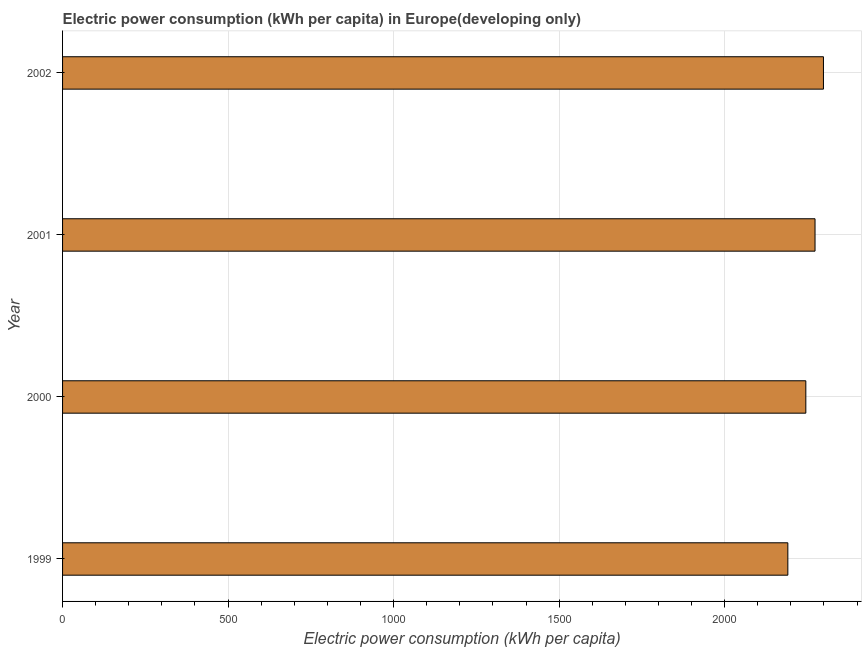Does the graph contain grids?
Make the answer very short. Yes. What is the title of the graph?
Offer a terse response. Electric power consumption (kWh per capita) in Europe(developing only). What is the label or title of the X-axis?
Offer a terse response. Electric power consumption (kWh per capita). What is the electric power consumption in 2000?
Give a very brief answer. 2245.15. Across all years, what is the maximum electric power consumption?
Your answer should be very brief. 2298.36. Across all years, what is the minimum electric power consumption?
Your response must be concise. 2190.83. In which year was the electric power consumption minimum?
Make the answer very short. 1999. What is the sum of the electric power consumption?
Offer a terse response. 9007.29. What is the difference between the electric power consumption in 1999 and 2000?
Give a very brief answer. -54.33. What is the average electric power consumption per year?
Make the answer very short. 2251.82. What is the median electric power consumption?
Keep it short and to the point. 2259.05. In how many years, is the electric power consumption greater than 200 kWh per capita?
Provide a short and direct response. 4. Is the difference between the electric power consumption in 1999 and 2001 greater than the difference between any two years?
Offer a terse response. No. What is the difference between the highest and the second highest electric power consumption?
Offer a very short reply. 25.41. What is the difference between the highest and the lowest electric power consumption?
Ensure brevity in your answer.  107.54. In how many years, is the electric power consumption greater than the average electric power consumption taken over all years?
Your answer should be very brief. 2. How many bars are there?
Give a very brief answer. 4. Are all the bars in the graph horizontal?
Your answer should be compact. Yes. What is the difference between two consecutive major ticks on the X-axis?
Your response must be concise. 500. What is the Electric power consumption (kWh per capita) in 1999?
Give a very brief answer. 2190.83. What is the Electric power consumption (kWh per capita) of 2000?
Give a very brief answer. 2245.15. What is the Electric power consumption (kWh per capita) in 2001?
Your response must be concise. 2272.95. What is the Electric power consumption (kWh per capita) in 2002?
Offer a very short reply. 2298.36. What is the difference between the Electric power consumption (kWh per capita) in 1999 and 2000?
Make the answer very short. -54.33. What is the difference between the Electric power consumption (kWh per capita) in 1999 and 2001?
Give a very brief answer. -82.12. What is the difference between the Electric power consumption (kWh per capita) in 1999 and 2002?
Keep it short and to the point. -107.54. What is the difference between the Electric power consumption (kWh per capita) in 2000 and 2001?
Keep it short and to the point. -27.8. What is the difference between the Electric power consumption (kWh per capita) in 2000 and 2002?
Your response must be concise. -53.21. What is the difference between the Electric power consumption (kWh per capita) in 2001 and 2002?
Give a very brief answer. -25.41. What is the ratio of the Electric power consumption (kWh per capita) in 1999 to that in 2001?
Provide a succinct answer. 0.96. What is the ratio of the Electric power consumption (kWh per capita) in 1999 to that in 2002?
Give a very brief answer. 0.95. What is the ratio of the Electric power consumption (kWh per capita) in 2000 to that in 2001?
Your answer should be compact. 0.99. What is the ratio of the Electric power consumption (kWh per capita) in 2000 to that in 2002?
Ensure brevity in your answer.  0.98. 